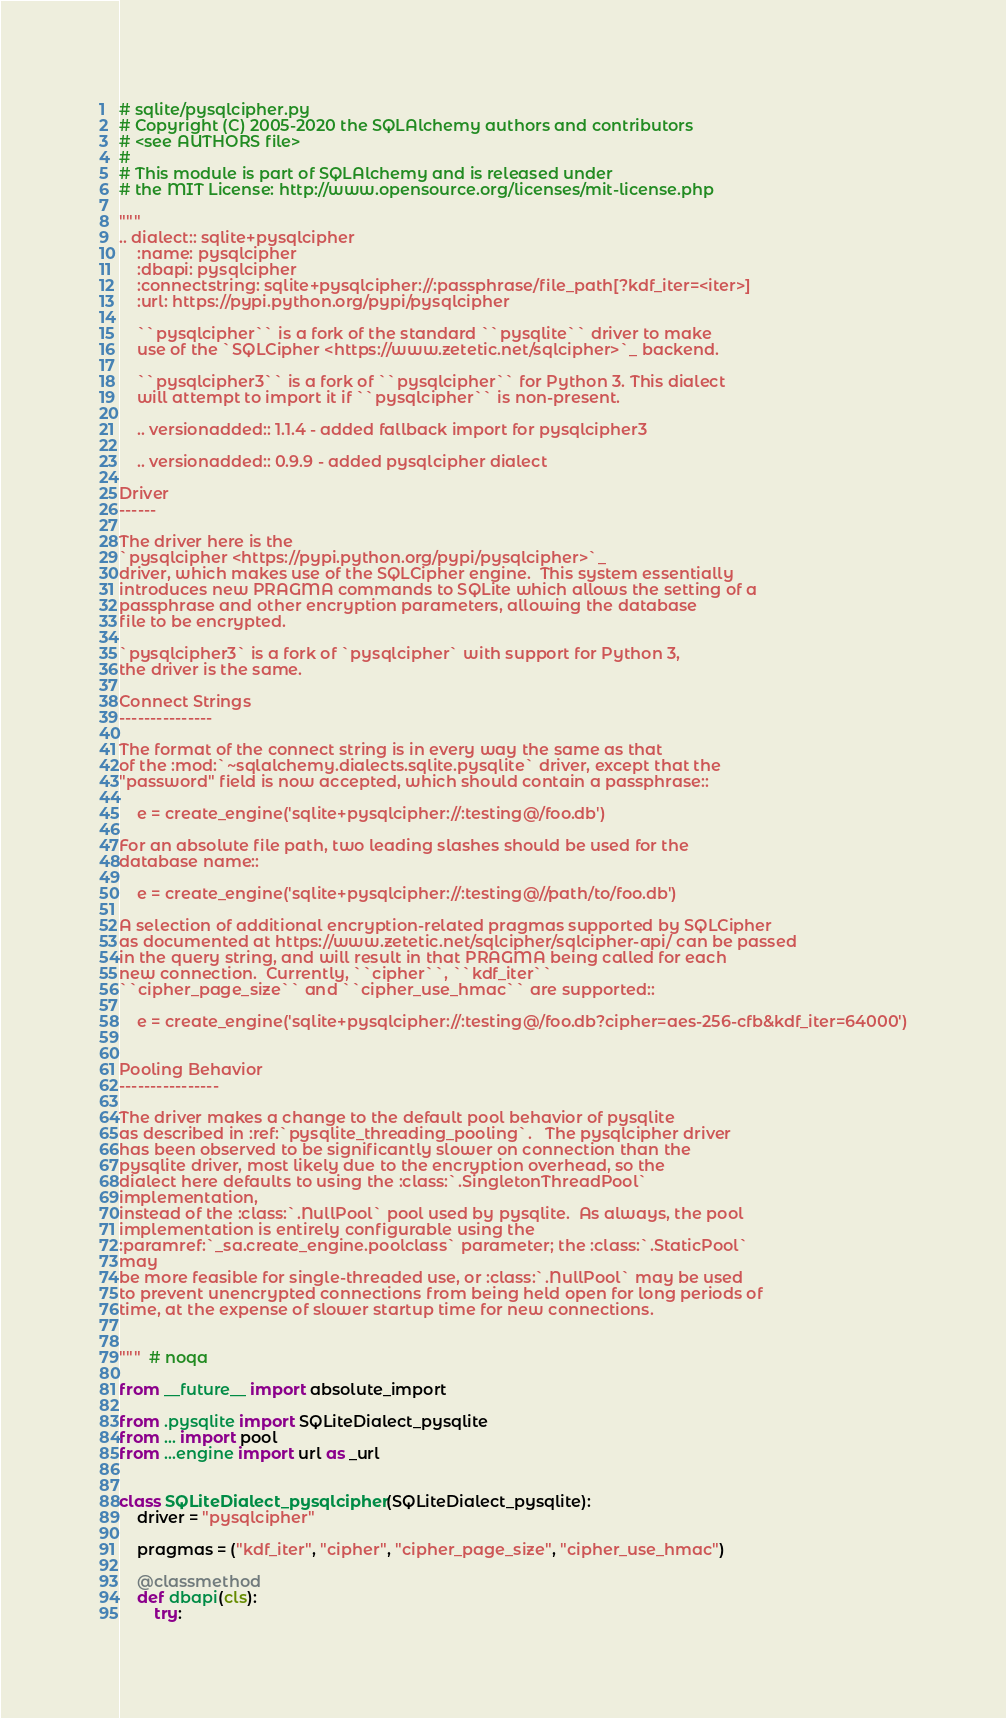<code> <loc_0><loc_0><loc_500><loc_500><_Python_># sqlite/pysqlcipher.py
# Copyright (C) 2005-2020 the SQLAlchemy authors and contributors
# <see AUTHORS file>
#
# This module is part of SQLAlchemy and is released under
# the MIT License: http://www.opensource.org/licenses/mit-license.php

"""
.. dialect:: sqlite+pysqlcipher
    :name: pysqlcipher
    :dbapi: pysqlcipher
    :connectstring: sqlite+pysqlcipher://:passphrase/file_path[?kdf_iter=<iter>]
    :url: https://pypi.python.org/pypi/pysqlcipher

    ``pysqlcipher`` is a fork of the standard ``pysqlite`` driver to make
    use of the `SQLCipher <https://www.zetetic.net/sqlcipher>`_ backend.

    ``pysqlcipher3`` is a fork of ``pysqlcipher`` for Python 3. This dialect
    will attempt to import it if ``pysqlcipher`` is non-present.

    .. versionadded:: 1.1.4 - added fallback import for pysqlcipher3

    .. versionadded:: 0.9.9 - added pysqlcipher dialect

Driver
------

The driver here is the
`pysqlcipher <https://pypi.python.org/pypi/pysqlcipher>`_
driver, which makes use of the SQLCipher engine.  This system essentially
introduces new PRAGMA commands to SQLite which allows the setting of a
passphrase and other encryption parameters, allowing the database
file to be encrypted.

`pysqlcipher3` is a fork of `pysqlcipher` with support for Python 3,
the driver is the same.

Connect Strings
---------------

The format of the connect string is in every way the same as that
of the :mod:`~sqlalchemy.dialects.sqlite.pysqlite` driver, except that the
"password" field is now accepted, which should contain a passphrase::

    e = create_engine('sqlite+pysqlcipher://:testing@/foo.db')

For an absolute file path, two leading slashes should be used for the
database name::

    e = create_engine('sqlite+pysqlcipher://:testing@//path/to/foo.db')

A selection of additional encryption-related pragmas supported by SQLCipher
as documented at https://www.zetetic.net/sqlcipher/sqlcipher-api/ can be passed
in the query string, and will result in that PRAGMA being called for each
new connection.  Currently, ``cipher``, ``kdf_iter``
``cipher_page_size`` and ``cipher_use_hmac`` are supported::

    e = create_engine('sqlite+pysqlcipher://:testing@/foo.db?cipher=aes-256-cfb&kdf_iter=64000')


Pooling Behavior
----------------

The driver makes a change to the default pool behavior of pysqlite
as described in :ref:`pysqlite_threading_pooling`.   The pysqlcipher driver
has been observed to be significantly slower on connection than the
pysqlite driver, most likely due to the encryption overhead, so the
dialect here defaults to using the :class:`.SingletonThreadPool`
implementation,
instead of the :class:`.NullPool` pool used by pysqlite.  As always, the pool
implementation is entirely configurable using the
:paramref:`_sa.create_engine.poolclass` parameter; the :class:`.StaticPool`
may
be more feasible for single-threaded use, or :class:`.NullPool` may be used
to prevent unencrypted connections from being held open for long periods of
time, at the expense of slower startup time for new connections.


"""  # noqa

from __future__ import absolute_import

from .pysqlite import SQLiteDialect_pysqlite
from ... import pool
from ...engine import url as _url


class SQLiteDialect_pysqlcipher(SQLiteDialect_pysqlite):
    driver = "pysqlcipher"

    pragmas = ("kdf_iter", "cipher", "cipher_page_size", "cipher_use_hmac")

    @classmethod
    def dbapi(cls):
        try:</code> 